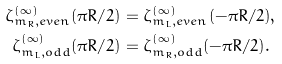Convert formula to latex. <formula><loc_0><loc_0><loc_500><loc_500>\zeta _ { { m _ { R } } , e v e n } ^ { ( \infty ) } ( \pi R / 2 ) & = \zeta _ { { m _ { L } } , e v e n } ^ { ( \infty ) } ( - \pi R / 2 ) , \\ \zeta _ { { m _ { L } } , o d d } ^ { ( \infty ) } ( \pi R / 2 ) & = \zeta _ { { m _ { R } } , o d d } ^ { ( \infty ) } ( - \pi R / 2 ) .</formula> 